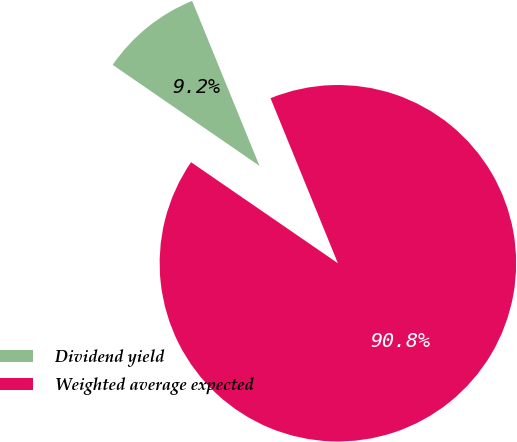Convert chart. <chart><loc_0><loc_0><loc_500><loc_500><pie_chart><fcel>Dividend yield<fcel>Weighted average expected<nl><fcel>9.24%<fcel>90.76%<nl></chart> 